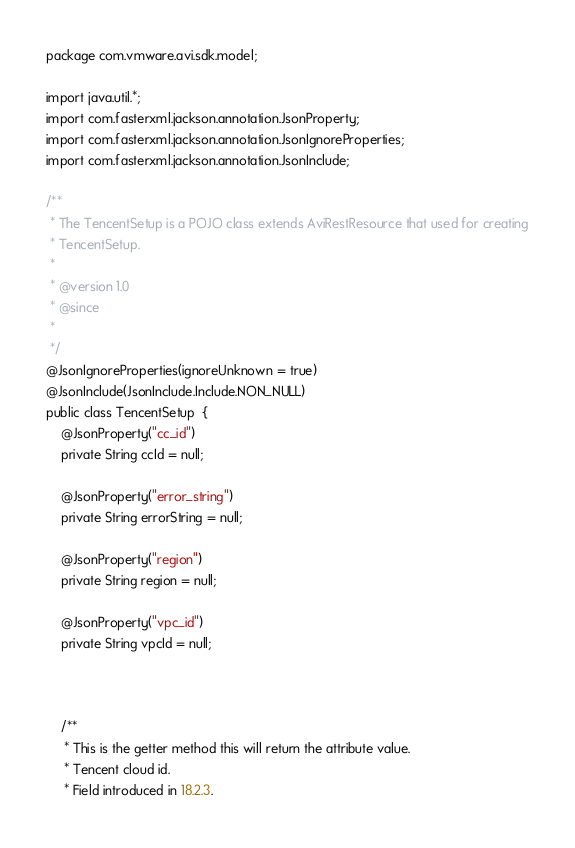<code> <loc_0><loc_0><loc_500><loc_500><_Java_>package com.vmware.avi.sdk.model;

import java.util.*;
import com.fasterxml.jackson.annotation.JsonProperty;
import com.fasterxml.jackson.annotation.JsonIgnoreProperties;
import com.fasterxml.jackson.annotation.JsonInclude;

/**
 * The TencentSetup is a POJO class extends AviRestResource that used for creating
 * TencentSetup.
 *
 * @version 1.0
 * @since 
 *
 */
@JsonIgnoreProperties(ignoreUnknown = true)
@JsonInclude(JsonInclude.Include.NON_NULL)
public class TencentSetup  {
    @JsonProperty("cc_id")
    private String ccId = null;

    @JsonProperty("error_string")
    private String errorString = null;

    @JsonProperty("region")
    private String region = null;

    @JsonProperty("vpc_id")
    private String vpcId = null;



    /**
     * This is the getter method this will return the attribute value.
     * Tencent cloud id.
     * Field introduced in 18.2.3.</code> 